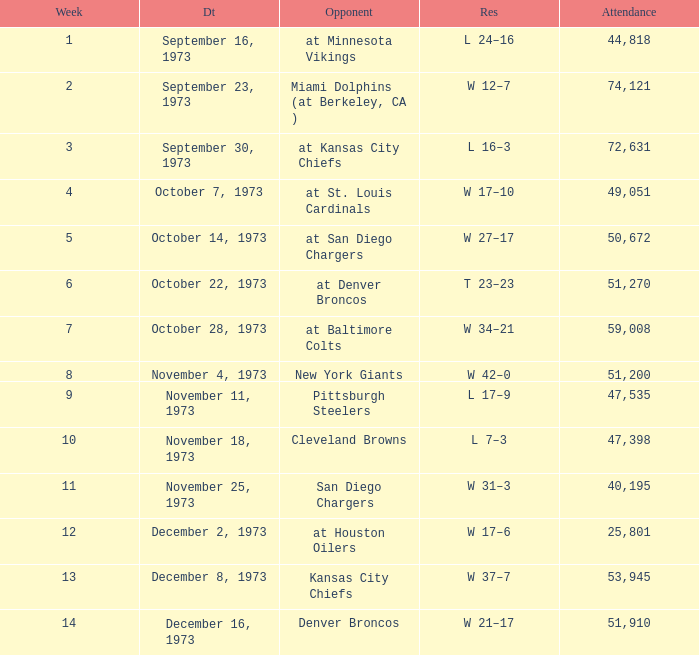What is the result later than week 13? W 21–17. 